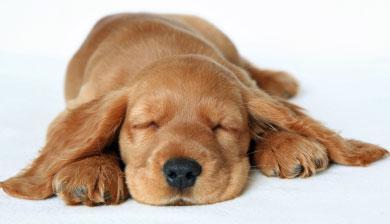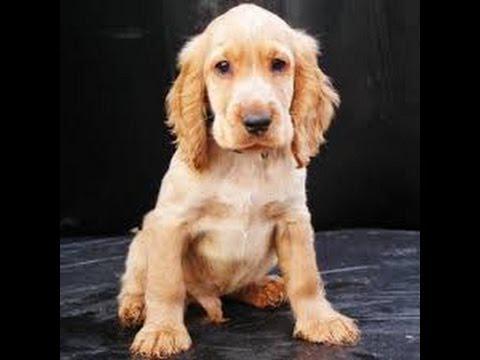The first image is the image on the left, the second image is the image on the right. Analyze the images presented: Is the assertion "A dog is lying on a leather sofa in both images." valid? Answer yes or no. No. 